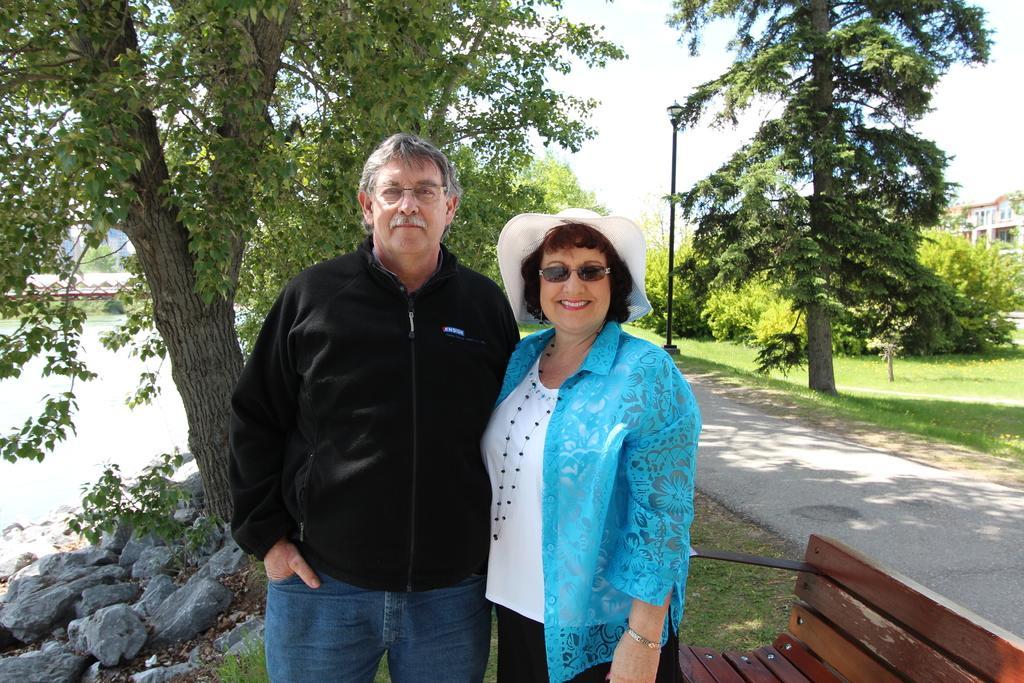In one or two sentences, can you explain what this image depicts? In this image I can see two person standing, the person at right is wearing blue and white shirt and black color pant, the person at left is wearing black shirt, blue pant. Background I can see few trees in green color, a light pole, building in cream color and the sky is in white color. 